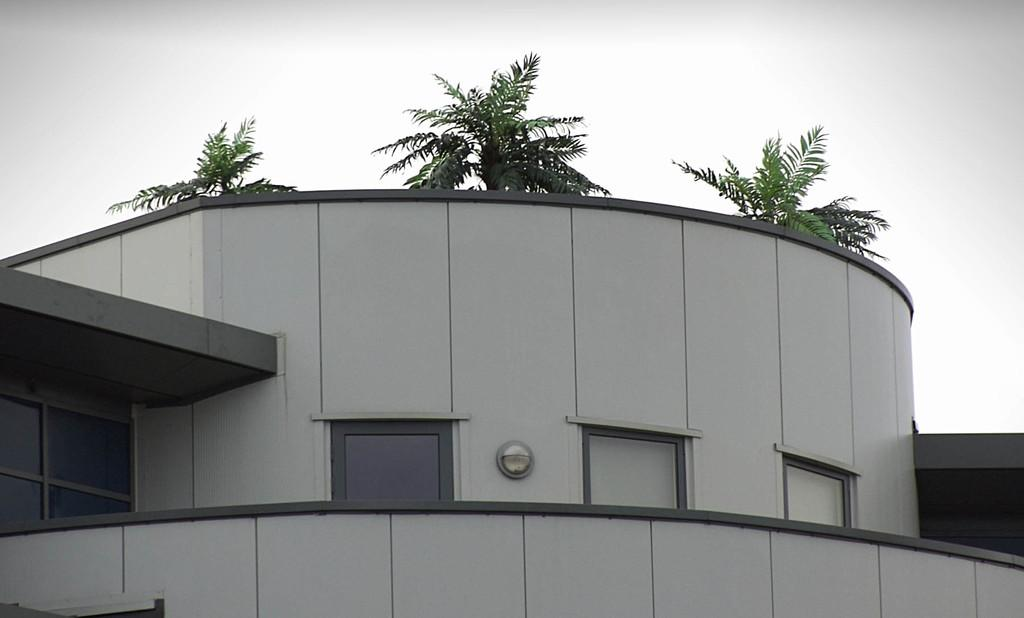What type of structure is present in the image? There is a building in the image. What feature can be observed on the building? The building has glass windows. What can be seen in the background of the image? There are trees and the sky visible in the background of the image. How many cherries are hanging from the trees in the image? There are no cherries visible in the image; only trees and the sky are present in the background. 